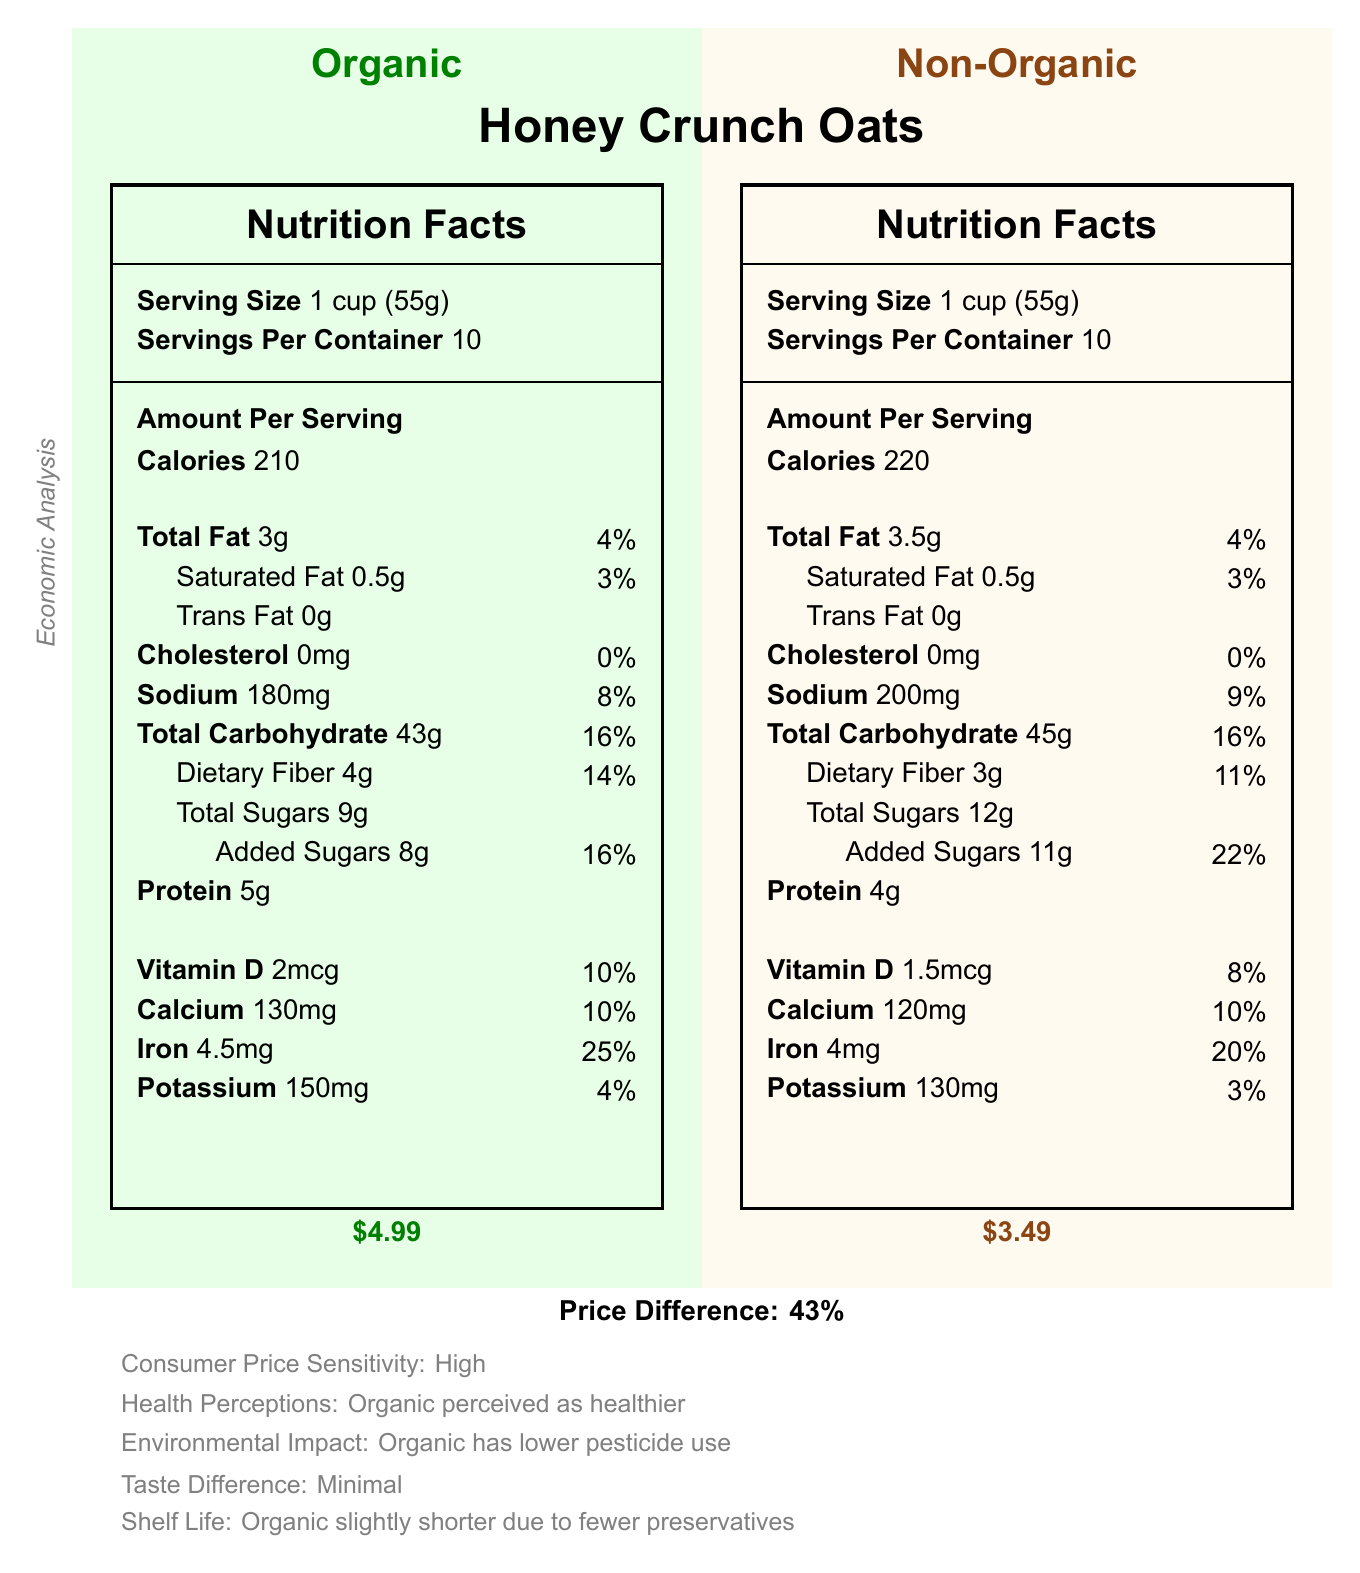what is the serving size for both versions of Honey Crunch Oats? The document specifies "Serving Size" as "1 cup (55g)" for both the organic and non-organic versions.
Answer: 1 cup (55g) how many calories does the organic version of Honey Crunch Oats contain per serving? The document shows that the organic version has "Calories 210" per serving.
Answer: 210 what is the main difference in sodium content between the organic and non-organic versions? In the Nutrition Facts section, the sodium content for the organic version is listed as 180mg, whereas it is listed as 200mg for the non-organic version.
Answer: The organic version contains 180mg of sodium, while the non-organic version contains 200mg of sodium. how much protein does the organic version provide per serving? The Nutrition Facts label for the organic version lists "Protein 5g."
Answer: 5g which version has a higher dietary fiber content and by how much? The organic version contains 4g of dietary fiber, while the non-organic version contains 3g.
Answer: The organic version has higher dietary fiber content by 1g. what is the percent daily value of iron in the non-organic version? The document lists "Iron 4mg" with a "percent daily value" of 20% for the non-organic version.
Answer: 20% what is the price difference between the organic and non-organic versions of Honey Crunch Oats? A. $1.50 B. $2.00 C. $3.00 D. $1.00 The document shows the price of the organic version as $4.99 and the non-organic version as $3.49, making the difference $1.50.
Answer: A. $1.50 which version has more vitamin D? A. Organic B. Non-Organic C. Both have the same The document lists "Vitamin D 2mcg" for the organic version and "Vitamin D 1.5mcg" for the non-organic version, making the organic version have more vitamin D.
Answer: A. Organic are there any trans fats in either version of Honey Crunch Oats? The document states "Trans Fat 0g" for both the organic and non-organic versions.
Answer: No what's the main idea conveyed by this document? The document provides a comprehensive comparison between the organic and non-organic versions of the cereal in terms of their nutritional content, price, market demand, and other practical considerations.
Answer: The document compares the nutritional facts, economic analysis, and practical implications of the organic and non-organic versions of 'Honey Crunch Oats' cereal, highlighting differences in nutritional components, consumer price sensitivity, and market trends. does the document specify which version has a longer shelf life? The document mentions that the shelf life of the organic version is slightly shorter due to fewer preservatives.
Answer: Yes how many grams of added sugars are in the organic version? The document lists "Added Sugars 8g" for the organic version.
Answer: 8g what are the production cost factors for the organic version of Honey Crunch Oats? The document lists "Organic certification, Higher labor costs, Lower crop yields, More expensive ingredients" under production cost factors for the organic version.
Answer: Organic certification, Higher labor costs, Lower crop yields, More expensive ingredients can you determine the transportation cost explicitly for the non-organic version from the document? The document mentions higher transportation costs for the organic version due to smaller batch sizes but does not provide explicit transportation costs for either version.
Answer: Cannot be determined what percent daily value of dietary fiber does the organic version provide? The document lists dietary fiber content with a "percent daily value" of 14% for the organic version.
Answer: 14% what is the difference in the total carbohydrate content between the two versions? The organic version has 43g of total carbohydrates per serving, while the non-organic version has 45g, making the difference 2g.
Answer: 2g 